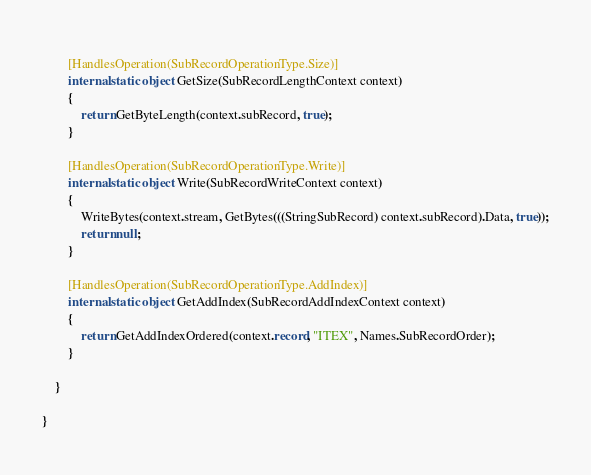Convert code to text. <code><loc_0><loc_0><loc_500><loc_500><_C#_>		
		[HandlesOperation(SubRecordOperationType.Size)]
		internal static object GetSize(SubRecordLengthContext context)
		{
            return GetByteLength(context.subRecord, true);
		}
		
		[HandlesOperation(SubRecordOperationType.Write)]
		internal static object Write(SubRecordWriteContext context)
		{
            WriteBytes(context.stream, GetBytes(((StringSubRecord) context.subRecord).Data, true));
			return null;
		}
		
		[HandlesOperation(SubRecordOperationType.AddIndex)]
		internal static object GetAddIndex(SubRecordAddIndexContext context)
		{
			return GetAddIndexOrdered(context.record, "ITEX", Names.SubRecordOrder);
		}
		
	}
	
}
</code> 